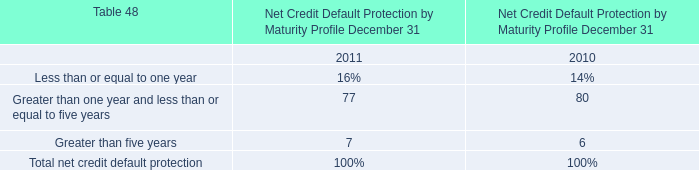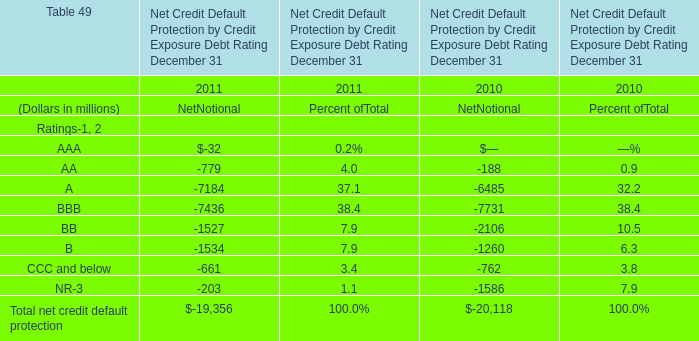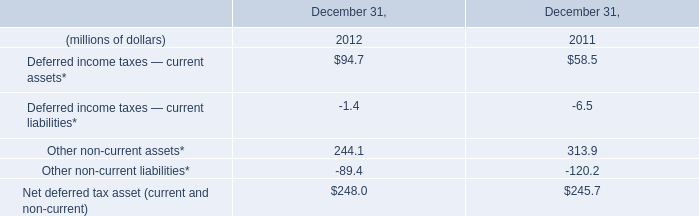How many Ratings keeps increasing between 2011 and 2010? 
Answer: 4. 